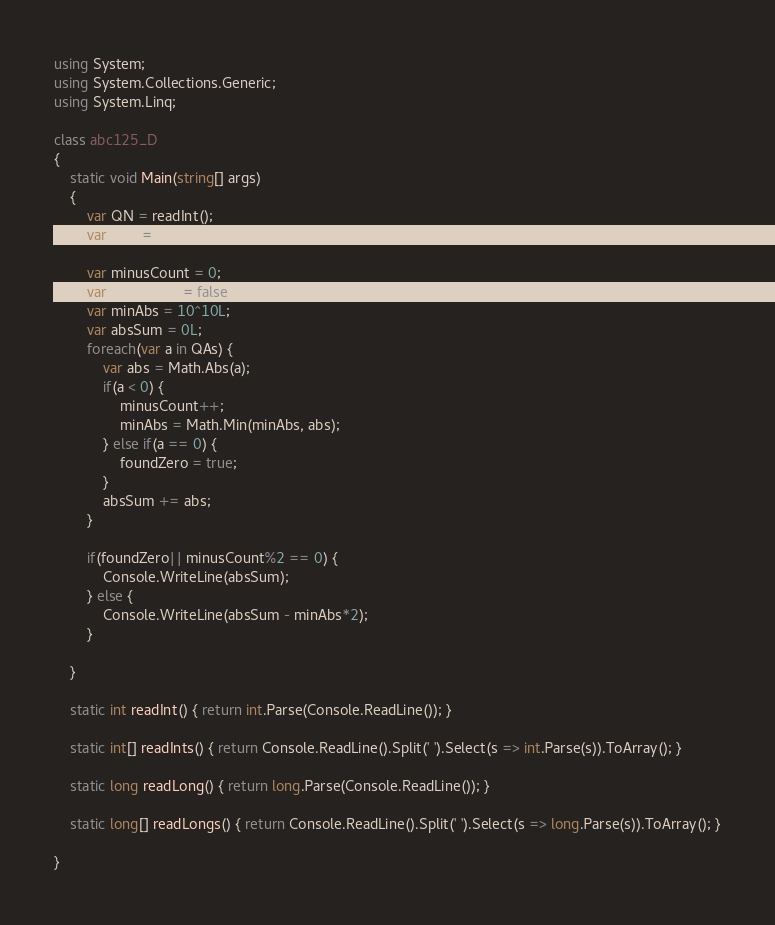<code> <loc_0><loc_0><loc_500><loc_500><_C#_>using System;
using System.Collections.Generic;
using System.Linq;

class abc125_D
{
    static void Main(string[] args)
    {
        var QN = readInt();
        var QAs = readLongs();

        var minusCount = 0;
        var foundZero = false;
        var minAbs = 10^10L;
        var absSum = 0L;
        foreach(var a in QAs) {
            var abs = Math.Abs(a);
            if(a < 0) {
                minusCount++;
                minAbs = Math.Min(minAbs, abs);
            } else if(a == 0) {
                foundZero = true;
            }
            absSum += abs;
        }

        if(foundZero|| minusCount%2 == 0) {
            Console.WriteLine(absSum);
        } else {
            Console.WriteLine(absSum - minAbs*2);
        }

    }

    static int readInt() { return int.Parse(Console.ReadLine()); }

    static int[] readInts() { return Console.ReadLine().Split(' ').Select(s => int.Parse(s)).ToArray(); }

    static long readLong() { return long.Parse(Console.ReadLine()); }

    static long[] readLongs() { return Console.ReadLine().Split(' ').Select(s => long.Parse(s)).ToArray(); }

}</code> 